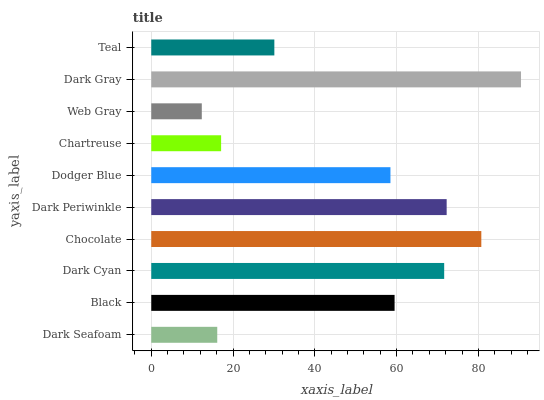Is Web Gray the minimum?
Answer yes or no. Yes. Is Dark Gray the maximum?
Answer yes or no. Yes. Is Black the minimum?
Answer yes or no. No. Is Black the maximum?
Answer yes or no. No. Is Black greater than Dark Seafoam?
Answer yes or no. Yes. Is Dark Seafoam less than Black?
Answer yes or no. Yes. Is Dark Seafoam greater than Black?
Answer yes or no. No. Is Black less than Dark Seafoam?
Answer yes or no. No. Is Black the high median?
Answer yes or no. Yes. Is Dodger Blue the low median?
Answer yes or no. Yes. Is Chocolate the high median?
Answer yes or no. No. Is Web Gray the low median?
Answer yes or no. No. 